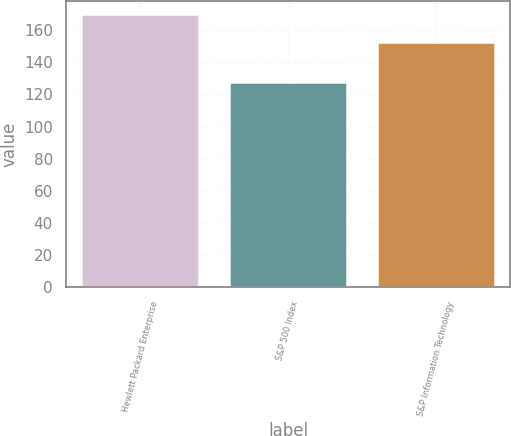Convert chart. <chart><loc_0><loc_0><loc_500><loc_500><bar_chart><fcel>Hewlett Packard Enterprise<fcel>S&P 500 Index<fcel>S&P Information Technology<nl><fcel>169.8<fcel>127.67<fcel>152.49<nl></chart> 